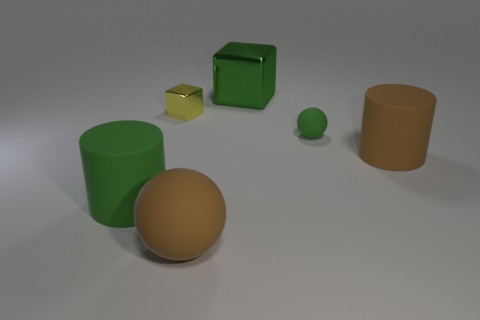What shape is the object that is the same color as the large sphere?
Your response must be concise. Cylinder. Are there any other things that have the same material as the brown cylinder?
Offer a very short reply. Yes. How many large things are either green cylinders or green metallic things?
Provide a short and direct response. 2. Is the shape of the large brown matte object on the left side of the tiny green ball the same as  the large metallic object?
Provide a succinct answer. No. Are there fewer green matte balls than matte cylinders?
Give a very brief answer. Yes. Is there anything else of the same color as the small rubber sphere?
Offer a terse response. Yes. There is a green matte thing that is right of the small yellow thing; what is its shape?
Provide a short and direct response. Sphere. Does the small cube have the same color as the big thing behind the green ball?
Provide a succinct answer. No. Are there the same number of green matte things on the left side of the tiny rubber thing and metallic things that are left of the large shiny thing?
Offer a terse response. Yes. What number of other things are there of the same size as the yellow thing?
Provide a succinct answer. 1. 